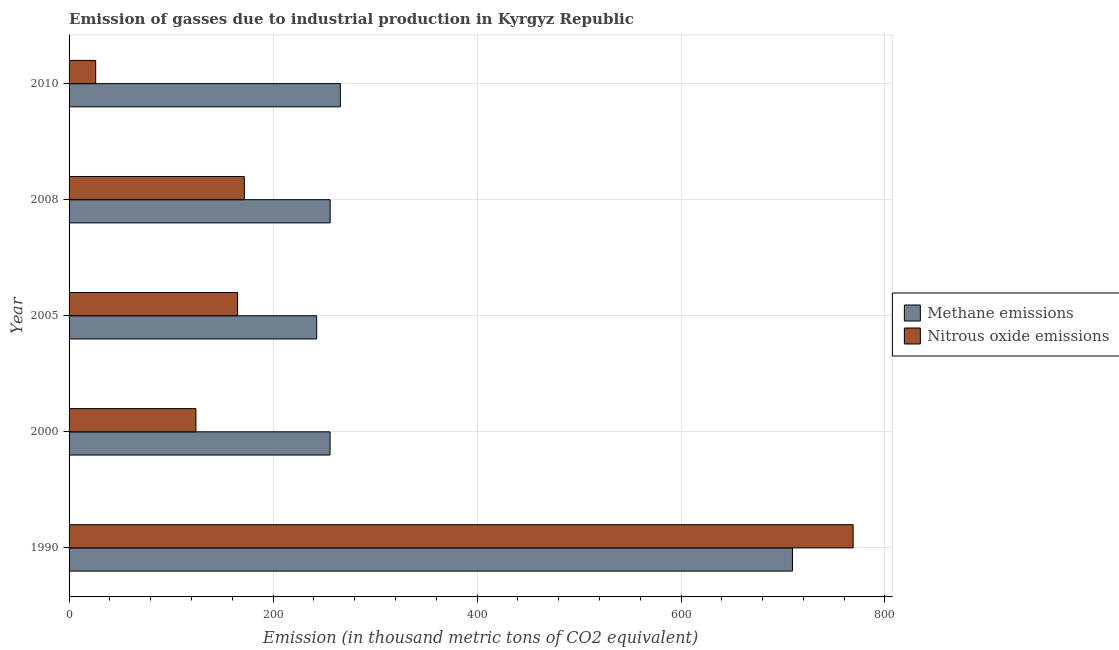Are the number of bars on each tick of the Y-axis equal?
Your response must be concise. Yes. How many bars are there on the 4th tick from the top?
Your response must be concise. 2. How many bars are there on the 1st tick from the bottom?
Provide a succinct answer. 2. In how many cases, is the number of bars for a given year not equal to the number of legend labels?
Your response must be concise. 0. What is the amount of nitrous oxide emissions in 2010?
Your response must be concise. 26.1. Across all years, what is the maximum amount of nitrous oxide emissions?
Ensure brevity in your answer.  768.8. Across all years, what is the minimum amount of nitrous oxide emissions?
Make the answer very short. 26.1. In which year was the amount of methane emissions minimum?
Give a very brief answer. 2005. What is the total amount of methane emissions in the graph?
Offer a very short reply. 1730. What is the difference between the amount of nitrous oxide emissions in 1990 and that in 2010?
Your answer should be very brief. 742.7. What is the difference between the amount of nitrous oxide emissions in 2000 and the amount of methane emissions in 2008?
Ensure brevity in your answer.  -131.6. What is the average amount of nitrous oxide emissions per year?
Give a very brief answer. 251.28. In the year 2010, what is the difference between the amount of nitrous oxide emissions and amount of methane emissions?
Ensure brevity in your answer.  -239.9. What is the ratio of the amount of nitrous oxide emissions in 1990 to that in 2005?
Keep it short and to the point. 4.65. Is the amount of nitrous oxide emissions in 2000 less than that in 2008?
Your response must be concise. Yes. What is the difference between the highest and the second highest amount of methane emissions?
Give a very brief answer. 443.3. What is the difference between the highest and the lowest amount of nitrous oxide emissions?
Provide a short and direct response. 742.7. In how many years, is the amount of nitrous oxide emissions greater than the average amount of nitrous oxide emissions taken over all years?
Your response must be concise. 1. What does the 2nd bar from the top in 2000 represents?
Offer a very short reply. Methane emissions. What does the 2nd bar from the bottom in 2000 represents?
Your answer should be compact. Nitrous oxide emissions. How many years are there in the graph?
Your response must be concise. 5. Are the values on the major ticks of X-axis written in scientific E-notation?
Your response must be concise. No. Where does the legend appear in the graph?
Offer a terse response. Center right. What is the title of the graph?
Your response must be concise. Emission of gasses due to industrial production in Kyrgyz Republic. Does "Start a business" appear as one of the legend labels in the graph?
Your response must be concise. No. What is the label or title of the X-axis?
Your answer should be very brief. Emission (in thousand metric tons of CO2 equivalent). What is the Emission (in thousand metric tons of CO2 equivalent) of Methane emissions in 1990?
Offer a very short reply. 709.3. What is the Emission (in thousand metric tons of CO2 equivalent) in Nitrous oxide emissions in 1990?
Your answer should be compact. 768.8. What is the Emission (in thousand metric tons of CO2 equivalent) of Methane emissions in 2000?
Offer a very short reply. 255.9. What is the Emission (in thousand metric tons of CO2 equivalent) of Nitrous oxide emissions in 2000?
Your response must be concise. 124.4. What is the Emission (in thousand metric tons of CO2 equivalent) of Methane emissions in 2005?
Ensure brevity in your answer.  242.8. What is the Emission (in thousand metric tons of CO2 equivalent) in Nitrous oxide emissions in 2005?
Keep it short and to the point. 165.2. What is the Emission (in thousand metric tons of CO2 equivalent) in Methane emissions in 2008?
Keep it short and to the point. 256. What is the Emission (in thousand metric tons of CO2 equivalent) of Nitrous oxide emissions in 2008?
Provide a succinct answer. 171.9. What is the Emission (in thousand metric tons of CO2 equivalent) of Methane emissions in 2010?
Your answer should be compact. 266. What is the Emission (in thousand metric tons of CO2 equivalent) in Nitrous oxide emissions in 2010?
Your answer should be compact. 26.1. Across all years, what is the maximum Emission (in thousand metric tons of CO2 equivalent) in Methane emissions?
Offer a terse response. 709.3. Across all years, what is the maximum Emission (in thousand metric tons of CO2 equivalent) in Nitrous oxide emissions?
Your answer should be very brief. 768.8. Across all years, what is the minimum Emission (in thousand metric tons of CO2 equivalent) in Methane emissions?
Offer a terse response. 242.8. Across all years, what is the minimum Emission (in thousand metric tons of CO2 equivalent) in Nitrous oxide emissions?
Make the answer very short. 26.1. What is the total Emission (in thousand metric tons of CO2 equivalent) in Methane emissions in the graph?
Provide a succinct answer. 1730. What is the total Emission (in thousand metric tons of CO2 equivalent) of Nitrous oxide emissions in the graph?
Ensure brevity in your answer.  1256.4. What is the difference between the Emission (in thousand metric tons of CO2 equivalent) in Methane emissions in 1990 and that in 2000?
Your answer should be very brief. 453.4. What is the difference between the Emission (in thousand metric tons of CO2 equivalent) in Nitrous oxide emissions in 1990 and that in 2000?
Your answer should be compact. 644.4. What is the difference between the Emission (in thousand metric tons of CO2 equivalent) of Methane emissions in 1990 and that in 2005?
Offer a very short reply. 466.5. What is the difference between the Emission (in thousand metric tons of CO2 equivalent) in Nitrous oxide emissions in 1990 and that in 2005?
Offer a very short reply. 603.6. What is the difference between the Emission (in thousand metric tons of CO2 equivalent) of Methane emissions in 1990 and that in 2008?
Ensure brevity in your answer.  453.3. What is the difference between the Emission (in thousand metric tons of CO2 equivalent) of Nitrous oxide emissions in 1990 and that in 2008?
Your response must be concise. 596.9. What is the difference between the Emission (in thousand metric tons of CO2 equivalent) of Methane emissions in 1990 and that in 2010?
Ensure brevity in your answer.  443.3. What is the difference between the Emission (in thousand metric tons of CO2 equivalent) of Nitrous oxide emissions in 1990 and that in 2010?
Provide a short and direct response. 742.7. What is the difference between the Emission (in thousand metric tons of CO2 equivalent) in Nitrous oxide emissions in 2000 and that in 2005?
Give a very brief answer. -40.8. What is the difference between the Emission (in thousand metric tons of CO2 equivalent) in Methane emissions in 2000 and that in 2008?
Make the answer very short. -0.1. What is the difference between the Emission (in thousand metric tons of CO2 equivalent) in Nitrous oxide emissions in 2000 and that in 2008?
Your answer should be compact. -47.5. What is the difference between the Emission (in thousand metric tons of CO2 equivalent) of Methane emissions in 2000 and that in 2010?
Keep it short and to the point. -10.1. What is the difference between the Emission (in thousand metric tons of CO2 equivalent) of Nitrous oxide emissions in 2000 and that in 2010?
Offer a terse response. 98.3. What is the difference between the Emission (in thousand metric tons of CO2 equivalent) of Methane emissions in 2005 and that in 2010?
Your answer should be very brief. -23.2. What is the difference between the Emission (in thousand metric tons of CO2 equivalent) of Nitrous oxide emissions in 2005 and that in 2010?
Offer a very short reply. 139.1. What is the difference between the Emission (in thousand metric tons of CO2 equivalent) in Nitrous oxide emissions in 2008 and that in 2010?
Your answer should be very brief. 145.8. What is the difference between the Emission (in thousand metric tons of CO2 equivalent) in Methane emissions in 1990 and the Emission (in thousand metric tons of CO2 equivalent) in Nitrous oxide emissions in 2000?
Ensure brevity in your answer.  584.9. What is the difference between the Emission (in thousand metric tons of CO2 equivalent) in Methane emissions in 1990 and the Emission (in thousand metric tons of CO2 equivalent) in Nitrous oxide emissions in 2005?
Make the answer very short. 544.1. What is the difference between the Emission (in thousand metric tons of CO2 equivalent) in Methane emissions in 1990 and the Emission (in thousand metric tons of CO2 equivalent) in Nitrous oxide emissions in 2008?
Ensure brevity in your answer.  537.4. What is the difference between the Emission (in thousand metric tons of CO2 equivalent) of Methane emissions in 1990 and the Emission (in thousand metric tons of CO2 equivalent) of Nitrous oxide emissions in 2010?
Your response must be concise. 683.2. What is the difference between the Emission (in thousand metric tons of CO2 equivalent) in Methane emissions in 2000 and the Emission (in thousand metric tons of CO2 equivalent) in Nitrous oxide emissions in 2005?
Give a very brief answer. 90.7. What is the difference between the Emission (in thousand metric tons of CO2 equivalent) in Methane emissions in 2000 and the Emission (in thousand metric tons of CO2 equivalent) in Nitrous oxide emissions in 2008?
Your answer should be very brief. 84. What is the difference between the Emission (in thousand metric tons of CO2 equivalent) of Methane emissions in 2000 and the Emission (in thousand metric tons of CO2 equivalent) of Nitrous oxide emissions in 2010?
Provide a succinct answer. 229.8. What is the difference between the Emission (in thousand metric tons of CO2 equivalent) in Methane emissions in 2005 and the Emission (in thousand metric tons of CO2 equivalent) in Nitrous oxide emissions in 2008?
Make the answer very short. 70.9. What is the difference between the Emission (in thousand metric tons of CO2 equivalent) in Methane emissions in 2005 and the Emission (in thousand metric tons of CO2 equivalent) in Nitrous oxide emissions in 2010?
Provide a succinct answer. 216.7. What is the difference between the Emission (in thousand metric tons of CO2 equivalent) of Methane emissions in 2008 and the Emission (in thousand metric tons of CO2 equivalent) of Nitrous oxide emissions in 2010?
Your answer should be very brief. 229.9. What is the average Emission (in thousand metric tons of CO2 equivalent) of Methane emissions per year?
Provide a succinct answer. 346. What is the average Emission (in thousand metric tons of CO2 equivalent) of Nitrous oxide emissions per year?
Your answer should be very brief. 251.28. In the year 1990, what is the difference between the Emission (in thousand metric tons of CO2 equivalent) of Methane emissions and Emission (in thousand metric tons of CO2 equivalent) of Nitrous oxide emissions?
Give a very brief answer. -59.5. In the year 2000, what is the difference between the Emission (in thousand metric tons of CO2 equivalent) in Methane emissions and Emission (in thousand metric tons of CO2 equivalent) in Nitrous oxide emissions?
Keep it short and to the point. 131.5. In the year 2005, what is the difference between the Emission (in thousand metric tons of CO2 equivalent) in Methane emissions and Emission (in thousand metric tons of CO2 equivalent) in Nitrous oxide emissions?
Provide a succinct answer. 77.6. In the year 2008, what is the difference between the Emission (in thousand metric tons of CO2 equivalent) of Methane emissions and Emission (in thousand metric tons of CO2 equivalent) of Nitrous oxide emissions?
Your answer should be compact. 84.1. In the year 2010, what is the difference between the Emission (in thousand metric tons of CO2 equivalent) of Methane emissions and Emission (in thousand metric tons of CO2 equivalent) of Nitrous oxide emissions?
Offer a very short reply. 239.9. What is the ratio of the Emission (in thousand metric tons of CO2 equivalent) in Methane emissions in 1990 to that in 2000?
Keep it short and to the point. 2.77. What is the ratio of the Emission (in thousand metric tons of CO2 equivalent) of Nitrous oxide emissions in 1990 to that in 2000?
Provide a succinct answer. 6.18. What is the ratio of the Emission (in thousand metric tons of CO2 equivalent) of Methane emissions in 1990 to that in 2005?
Give a very brief answer. 2.92. What is the ratio of the Emission (in thousand metric tons of CO2 equivalent) in Nitrous oxide emissions in 1990 to that in 2005?
Your answer should be compact. 4.65. What is the ratio of the Emission (in thousand metric tons of CO2 equivalent) in Methane emissions in 1990 to that in 2008?
Provide a succinct answer. 2.77. What is the ratio of the Emission (in thousand metric tons of CO2 equivalent) of Nitrous oxide emissions in 1990 to that in 2008?
Offer a terse response. 4.47. What is the ratio of the Emission (in thousand metric tons of CO2 equivalent) in Methane emissions in 1990 to that in 2010?
Ensure brevity in your answer.  2.67. What is the ratio of the Emission (in thousand metric tons of CO2 equivalent) in Nitrous oxide emissions in 1990 to that in 2010?
Your response must be concise. 29.46. What is the ratio of the Emission (in thousand metric tons of CO2 equivalent) of Methane emissions in 2000 to that in 2005?
Give a very brief answer. 1.05. What is the ratio of the Emission (in thousand metric tons of CO2 equivalent) in Nitrous oxide emissions in 2000 to that in 2005?
Offer a terse response. 0.75. What is the ratio of the Emission (in thousand metric tons of CO2 equivalent) in Nitrous oxide emissions in 2000 to that in 2008?
Keep it short and to the point. 0.72. What is the ratio of the Emission (in thousand metric tons of CO2 equivalent) of Nitrous oxide emissions in 2000 to that in 2010?
Ensure brevity in your answer.  4.77. What is the ratio of the Emission (in thousand metric tons of CO2 equivalent) in Methane emissions in 2005 to that in 2008?
Make the answer very short. 0.95. What is the ratio of the Emission (in thousand metric tons of CO2 equivalent) of Nitrous oxide emissions in 2005 to that in 2008?
Your response must be concise. 0.96. What is the ratio of the Emission (in thousand metric tons of CO2 equivalent) in Methane emissions in 2005 to that in 2010?
Your response must be concise. 0.91. What is the ratio of the Emission (in thousand metric tons of CO2 equivalent) of Nitrous oxide emissions in 2005 to that in 2010?
Your response must be concise. 6.33. What is the ratio of the Emission (in thousand metric tons of CO2 equivalent) of Methane emissions in 2008 to that in 2010?
Provide a short and direct response. 0.96. What is the ratio of the Emission (in thousand metric tons of CO2 equivalent) in Nitrous oxide emissions in 2008 to that in 2010?
Your answer should be compact. 6.59. What is the difference between the highest and the second highest Emission (in thousand metric tons of CO2 equivalent) of Methane emissions?
Provide a short and direct response. 443.3. What is the difference between the highest and the second highest Emission (in thousand metric tons of CO2 equivalent) of Nitrous oxide emissions?
Offer a very short reply. 596.9. What is the difference between the highest and the lowest Emission (in thousand metric tons of CO2 equivalent) of Methane emissions?
Give a very brief answer. 466.5. What is the difference between the highest and the lowest Emission (in thousand metric tons of CO2 equivalent) of Nitrous oxide emissions?
Offer a terse response. 742.7. 